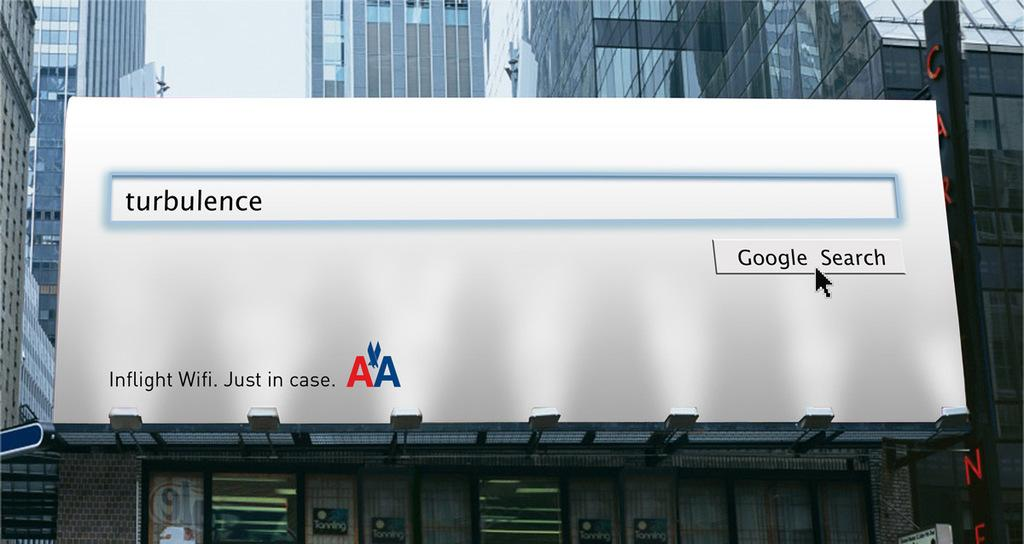Provide a one-sentence caption for the provided image. A billboard for American Airlines shows a Google search for the word turbulence. 